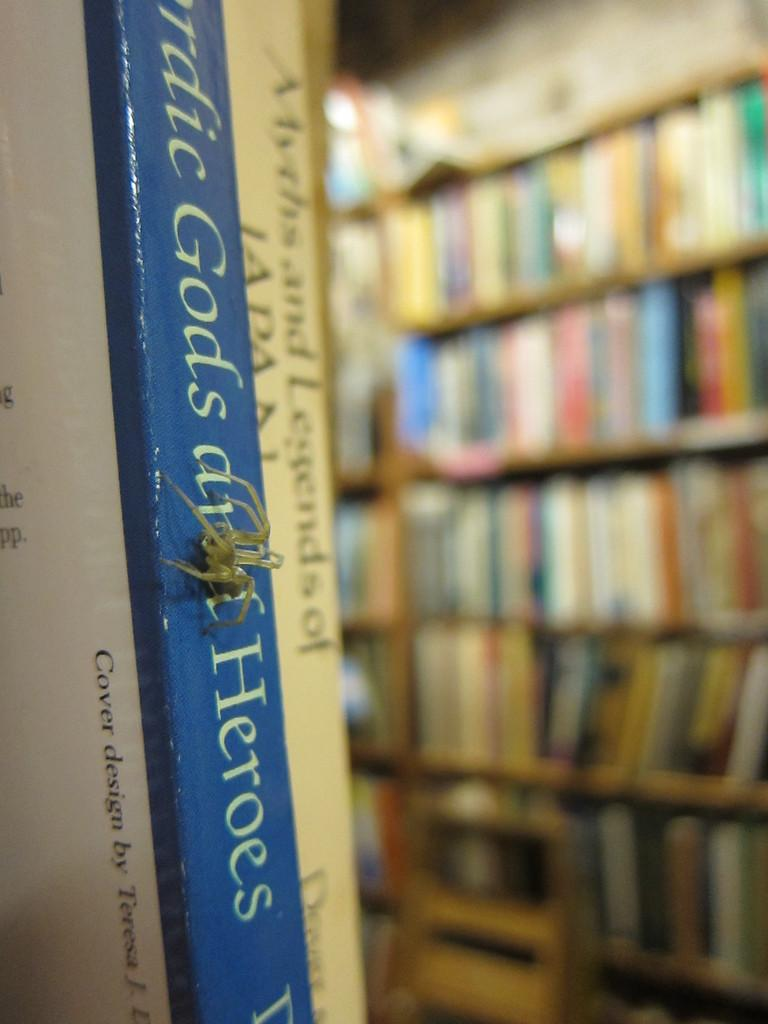<image>
Write a terse but informative summary of the picture. a book with the word heroes on ot 